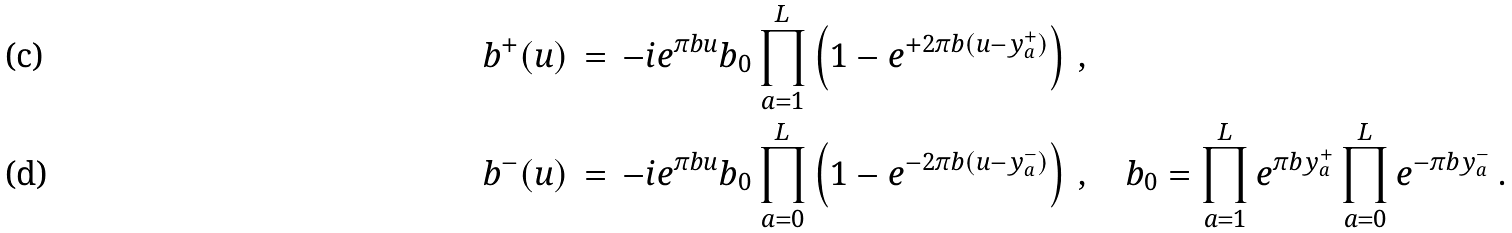Convert formula to latex. <formula><loc_0><loc_0><loc_500><loc_500>& b ^ { + } ( u ) \, = \, - i e ^ { \pi b u } b _ { 0 } \prod _ { a = 1 } ^ { L } \left ( 1 - e ^ { + 2 \pi b ( u - y _ { a } ^ { + } ) } \right ) \, , \\ & b ^ { - } ( u ) \, = \, - i e ^ { \pi b u } b _ { 0 } \prod _ { a = 0 } ^ { L } \left ( 1 - e ^ { - 2 \pi b ( u - y _ { a } ^ { - } ) } \right ) \, , \quad b _ { 0 } = \prod _ { a = 1 } ^ { L } e ^ { \pi b y _ { a } ^ { + } } \prod _ { a = 0 } ^ { L } e ^ { - \pi b y _ { a } ^ { - } } \, .</formula> 